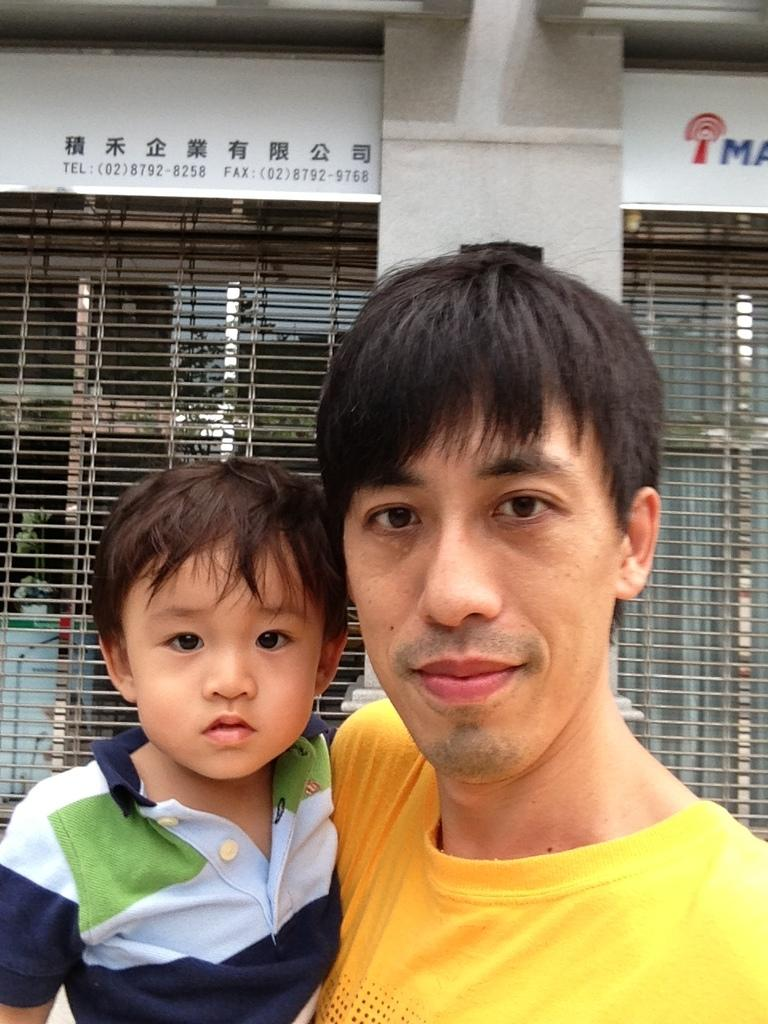Who is present in the image? There is a man and a kid in the image. What can be seen in the background of the image? There is a pillar and windows in the background of the image. What type of jail can be seen in the image? There is no jail present in the image; it features a man and a kid with a pillar and windows in the background. 